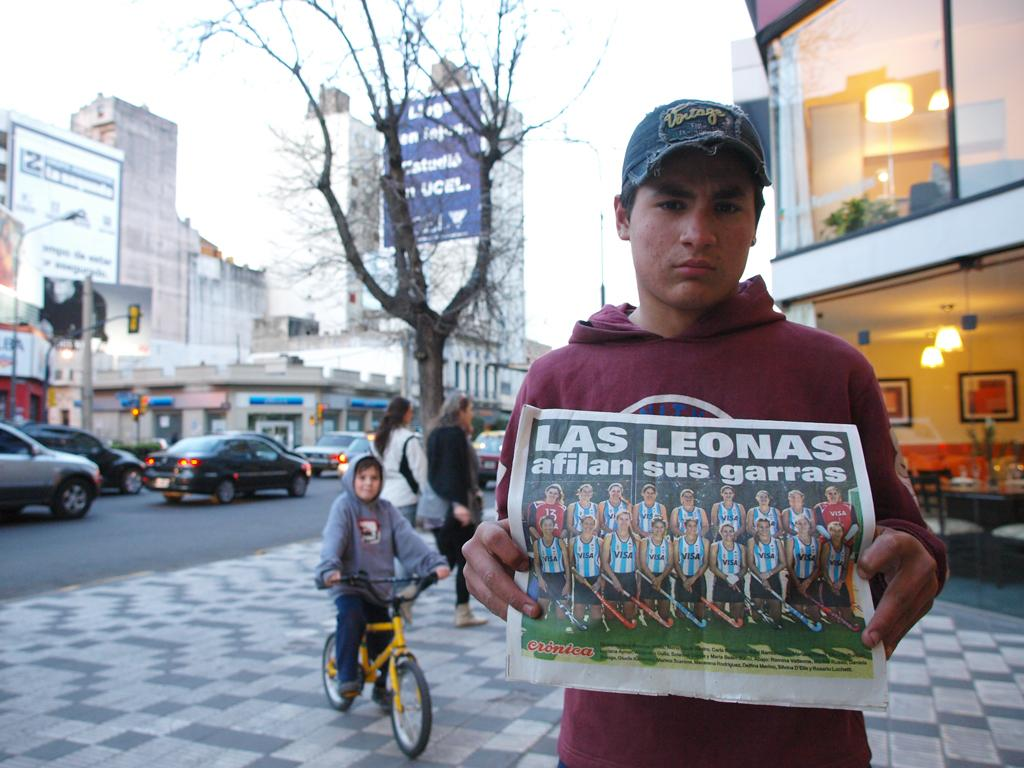Who is the main subject in the image? There is a boy in the image. What is the boy holding in the image? The boy is holding a poster. Where is the boy standing in the image? The boy is standing on a footpath. Are there any other people visible in the image? Yes, there are people behind the boy. What is happening in the background of the image? Cars are passing on the road. What type of cat is sitting on the boy's shoulder in the image? There is no cat present in the image; the boy is holding a poster. 